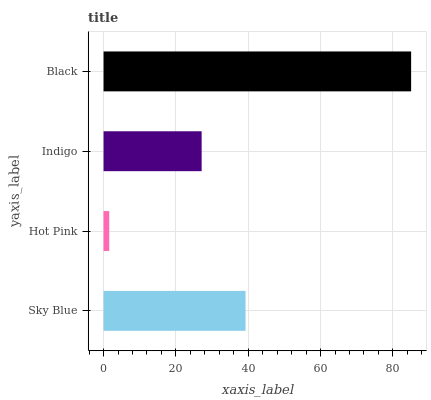Is Hot Pink the minimum?
Answer yes or no. Yes. Is Black the maximum?
Answer yes or no. Yes. Is Indigo the minimum?
Answer yes or no. No. Is Indigo the maximum?
Answer yes or no. No. Is Indigo greater than Hot Pink?
Answer yes or no. Yes. Is Hot Pink less than Indigo?
Answer yes or no. Yes. Is Hot Pink greater than Indigo?
Answer yes or no. No. Is Indigo less than Hot Pink?
Answer yes or no. No. Is Sky Blue the high median?
Answer yes or no. Yes. Is Indigo the low median?
Answer yes or no. Yes. Is Indigo the high median?
Answer yes or no. No. Is Black the low median?
Answer yes or no. No. 